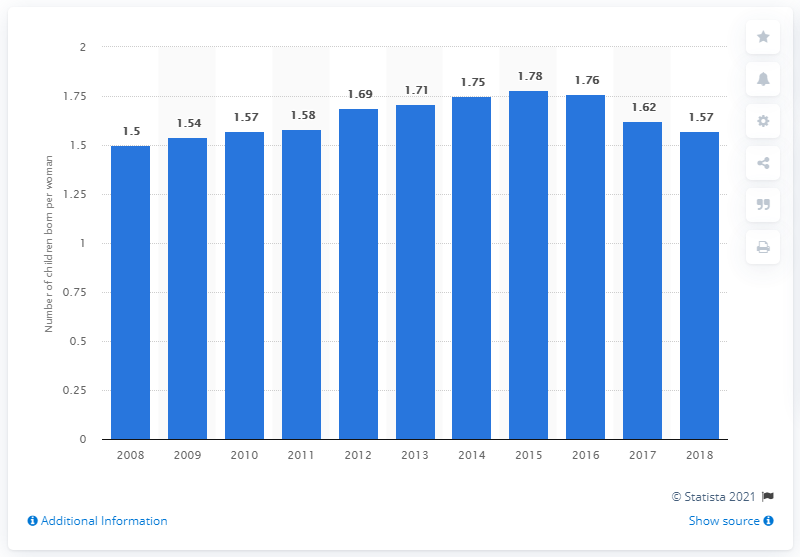Indicate a few pertinent items in this graphic. In 2018, the fertility rate of Russia's population was 1.57. 